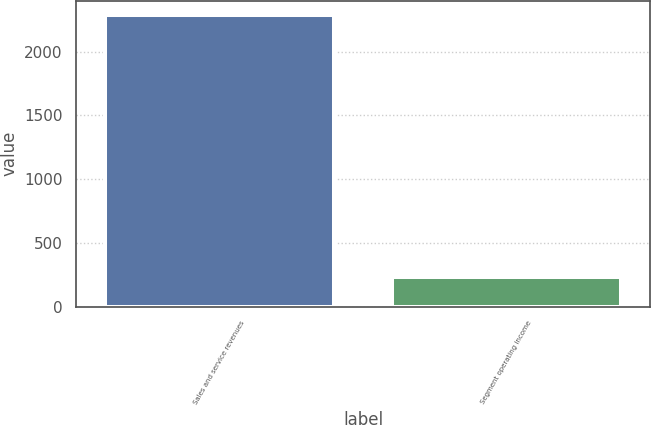<chart> <loc_0><loc_0><loc_500><loc_500><bar_chart><fcel>Sales and service revenues<fcel>Segment operating income<nl><fcel>2286<fcel>229<nl></chart> 